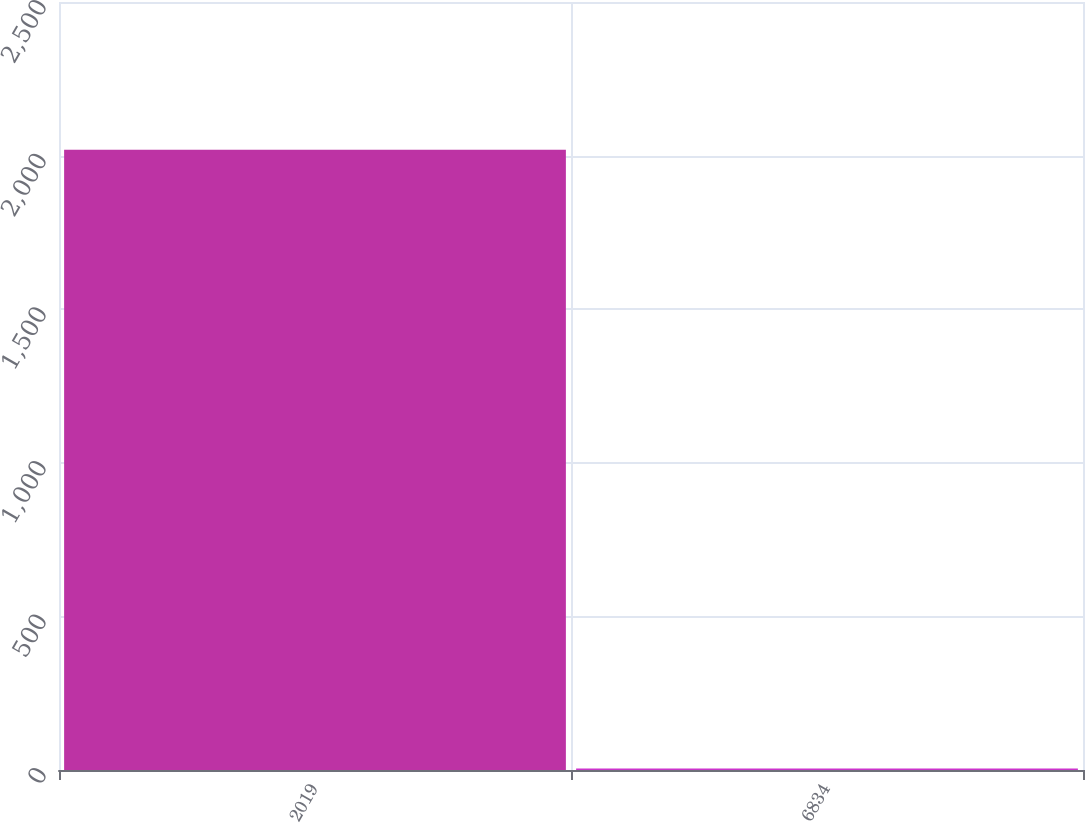Convert chart to OTSL. <chart><loc_0><loc_0><loc_500><loc_500><bar_chart><fcel>2019<fcel>6834<nl><fcel>2019<fcel>5<nl></chart> 